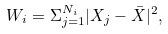<formula> <loc_0><loc_0><loc_500><loc_500>W _ { i } = \Sigma _ { j = 1 } ^ { N _ { i } } | X _ { j } - \bar { X } | ^ { 2 } ,</formula> 